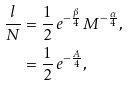Convert formula to latex. <formula><loc_0><loc_0><loc_500><loc_500>\frac { l } { N } & = \frac { 1 } { 2 } \, e ^ { - \frac { \beta } { 4 } } \, M ^ { - \frac { \alpha } { 4 } } , \\ & = \frac { 1 } { 2 } \, e ^ { - \frac { A } { 4 } } ,</formula> 